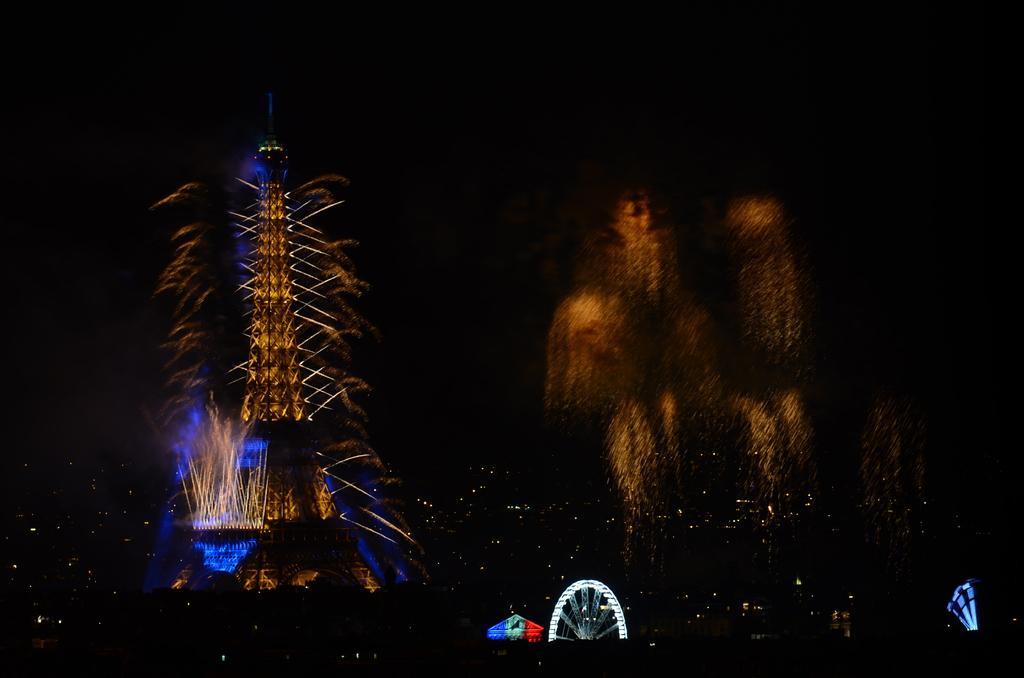In one or two sentences, can you explain what this image depicts? In the image there is an Eiffel tower with lights. At the bottom of the image there is a giant wheel with lights. In the image there are fireworks. And there is a dark background 